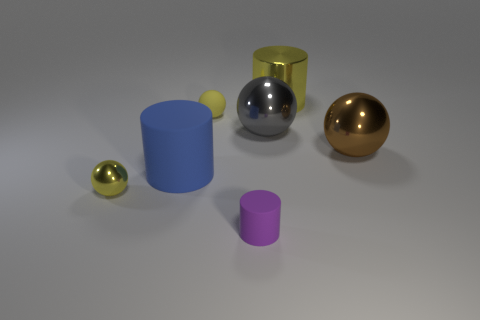Is the color of the tiny matte ball the same as the cylinder right of the purple rubber cylinder?
Provide a short and direct response. Yes. There is a cylinder that is the same size as the blue matte object; what material is it?
Your answer should be very brief. Metal. How many things are either small yellow matte spheres or big cylinders that are in front of the large brown shiny thing?
Your response must be concise. 2. Do the purple rubber object and the metal object behind the gray shiny ball have the same size?
Make the answer very short. No. What number of balls are either large gray objects or big objects?
Your answer should be compact. 2. What number of things are both left of the small purple matte object and in front of the brown thing?
Offer a terse response. 2. What number of other objects are there of the same color as the small metallic thing?
Your response must be concise. 2. There is a blue object on the left side of the gray metal thing; what shape is it?
Offer a terse response. Cylinder. Is the material of the big blue cylinder the same as the big gray sphere?
Offer a terse response. No. How many yellow shiny balls are in front of the blue thing?
Provide a short and direct response. 1. 